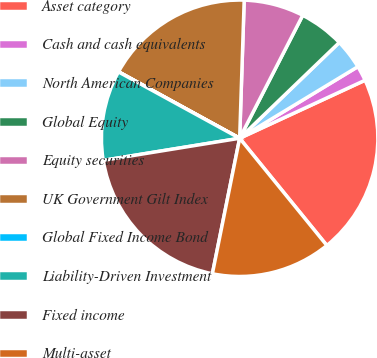Convert chart. <chart><loc_0><loc_0><loc_500><loc_500><pie_chart><fcel>Asset category<fcel>Cash and cash equivalents<fcel>North American Companies<fcel>Global Equity<fcel>Equity securities<fcel>UK Government Gilt Index<fcel>Global Fixed Income Bond<fcel>Liability-Driven Investment<fcel>Fixed income<fcel>Multi-asset<nl><fcel>21.03%<fcel>1.77%<fcel>3.52%<fcel>5.27%<fcel>7.02%<fcel>17.53%<fcel>0.02%<fcel>10.53%<fcel>19.28%<fcel>14.03%<nl></chart> 